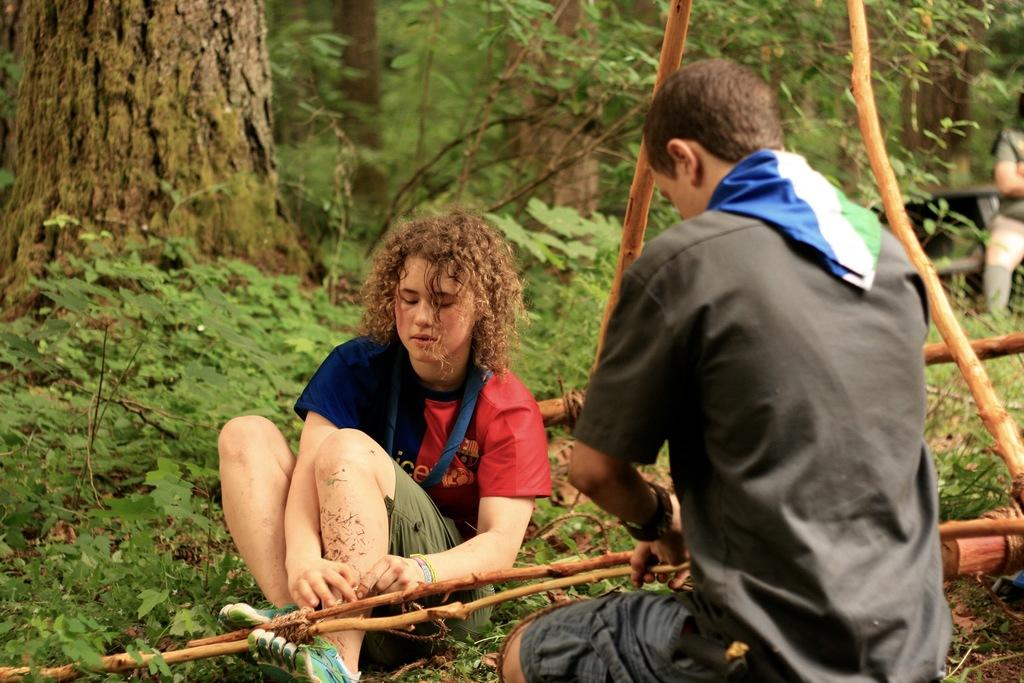What can be seen on the ground in the image? There are people on the ground in the image. What objects are visible in the image besides the people? There are sticks visible in the image. What type of natural scenery is visible in the background of the image? There are trees in the background of the image. Is there a volcano erupting in the background of the image? No, there is no volcano present in the image. What country is depicted in the image? The image does not show a specific country; it only shows people, sticks, and trees. 